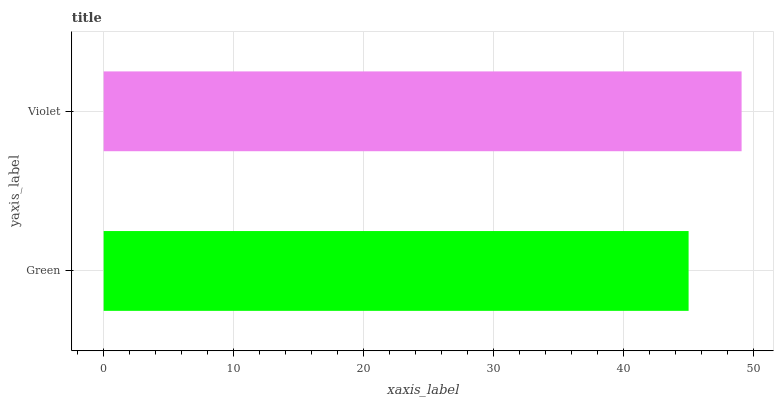Is Green the minimum?
Answer yes or no. Yes. Is Violet the maximum?
Answer yes or no. Yes. Is Violet the minimum?
Answer yes or no. No. Is Violet greater than Green?
Answer yes or no. Yes. Is Green less than Violet?
Answer yes or no. Yes. Is Green greater than Violet?
Answer yes or no. No. Is Violet less than Green?
Answer yes or no. No. Is Violet the high median?
Answer yes or no. Yes. Is Green the low median?
Answer yes or no. Yes. Is Green the high median?
Answer yes or no. No. Is Violet the low median?
Answer yes or no. No. 